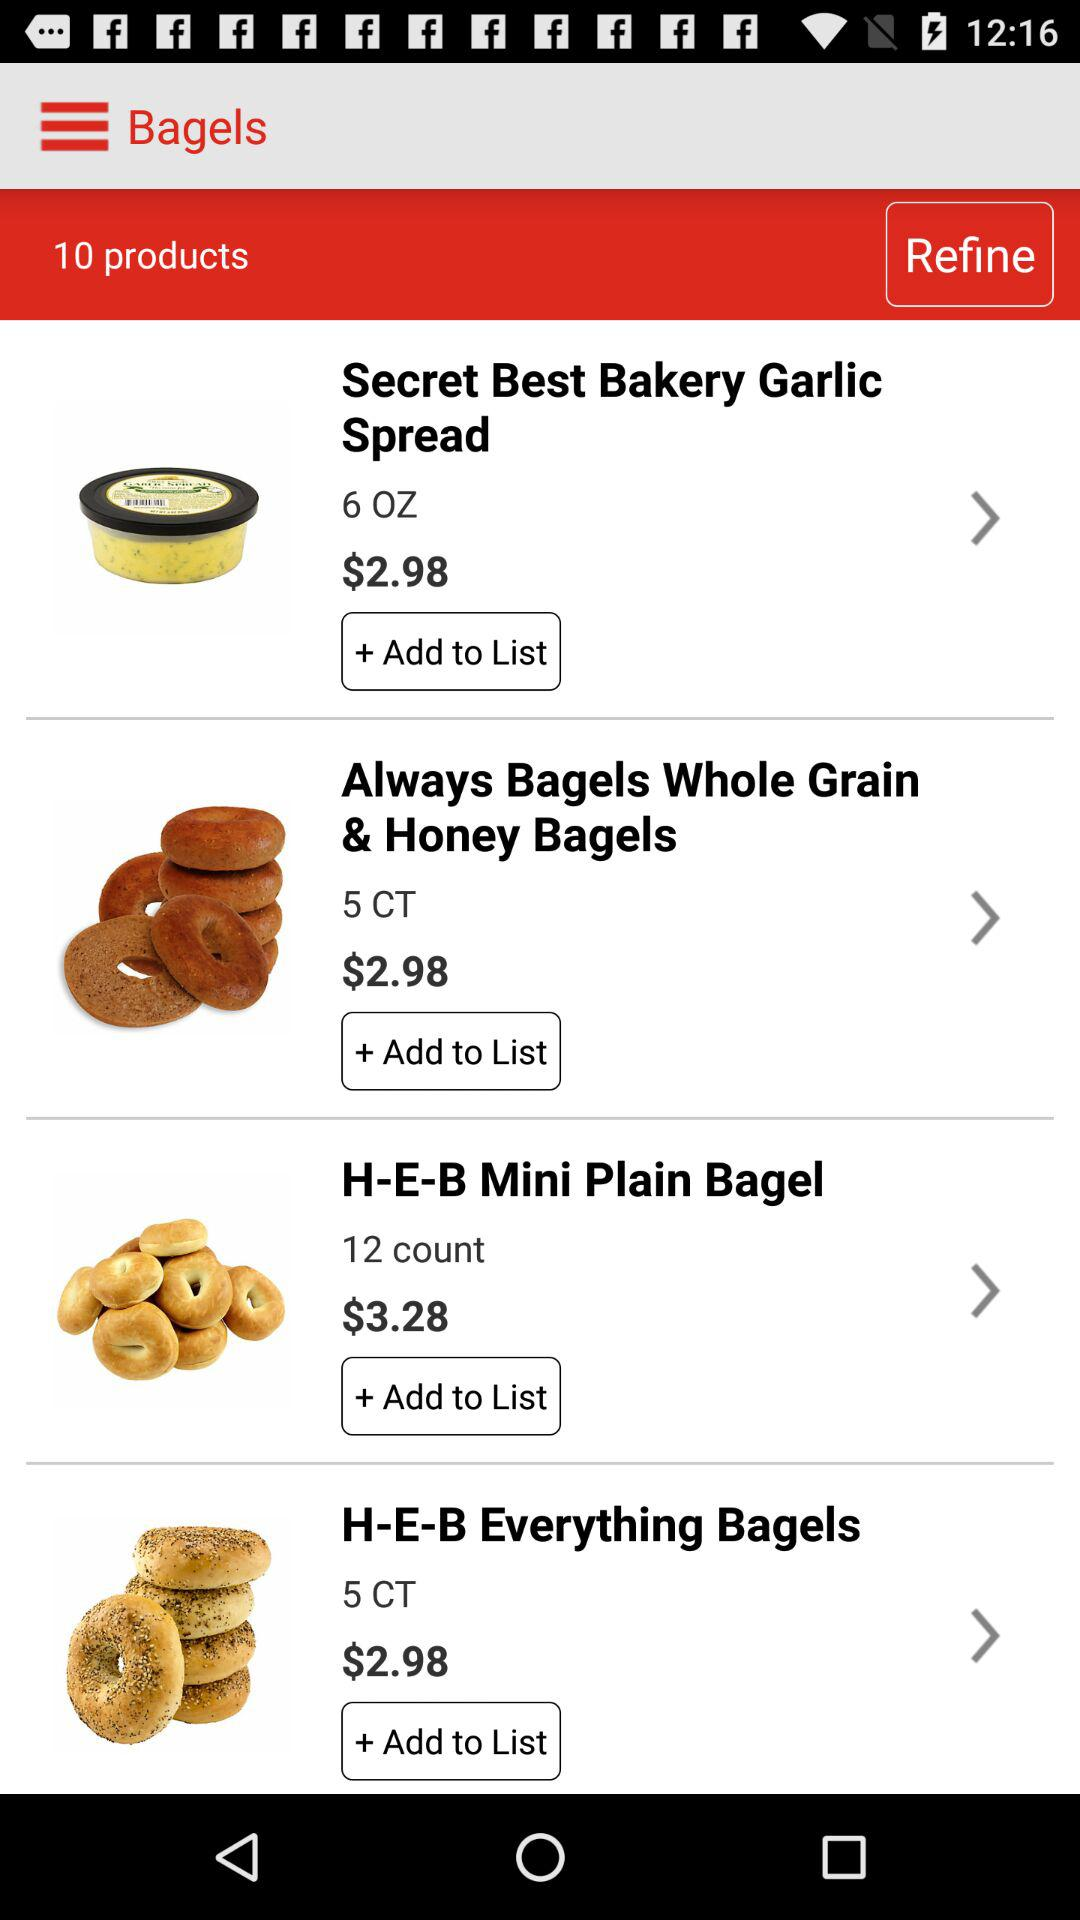What is the price of the Secret Best Bakery Garlic Spread? The price of the Secret Best Bakery Garlic Spread is $2.98. 